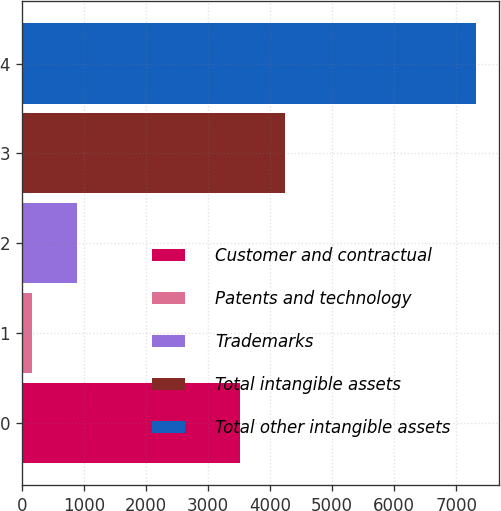Convert chart to OTSL. <chart><loc_0><loc_0><loc_500><loc_500><bar_chart><fcel>Customer and contractual<fcel>Patents and technology<fcel>Trademarks<fcel>Total intangible assets<fcel>Total other intangible assets<nl><fcel>3520.1<fcel>168.5<fcel>883.96<fcel>4245<fcel>7323.1<nl></chart> 